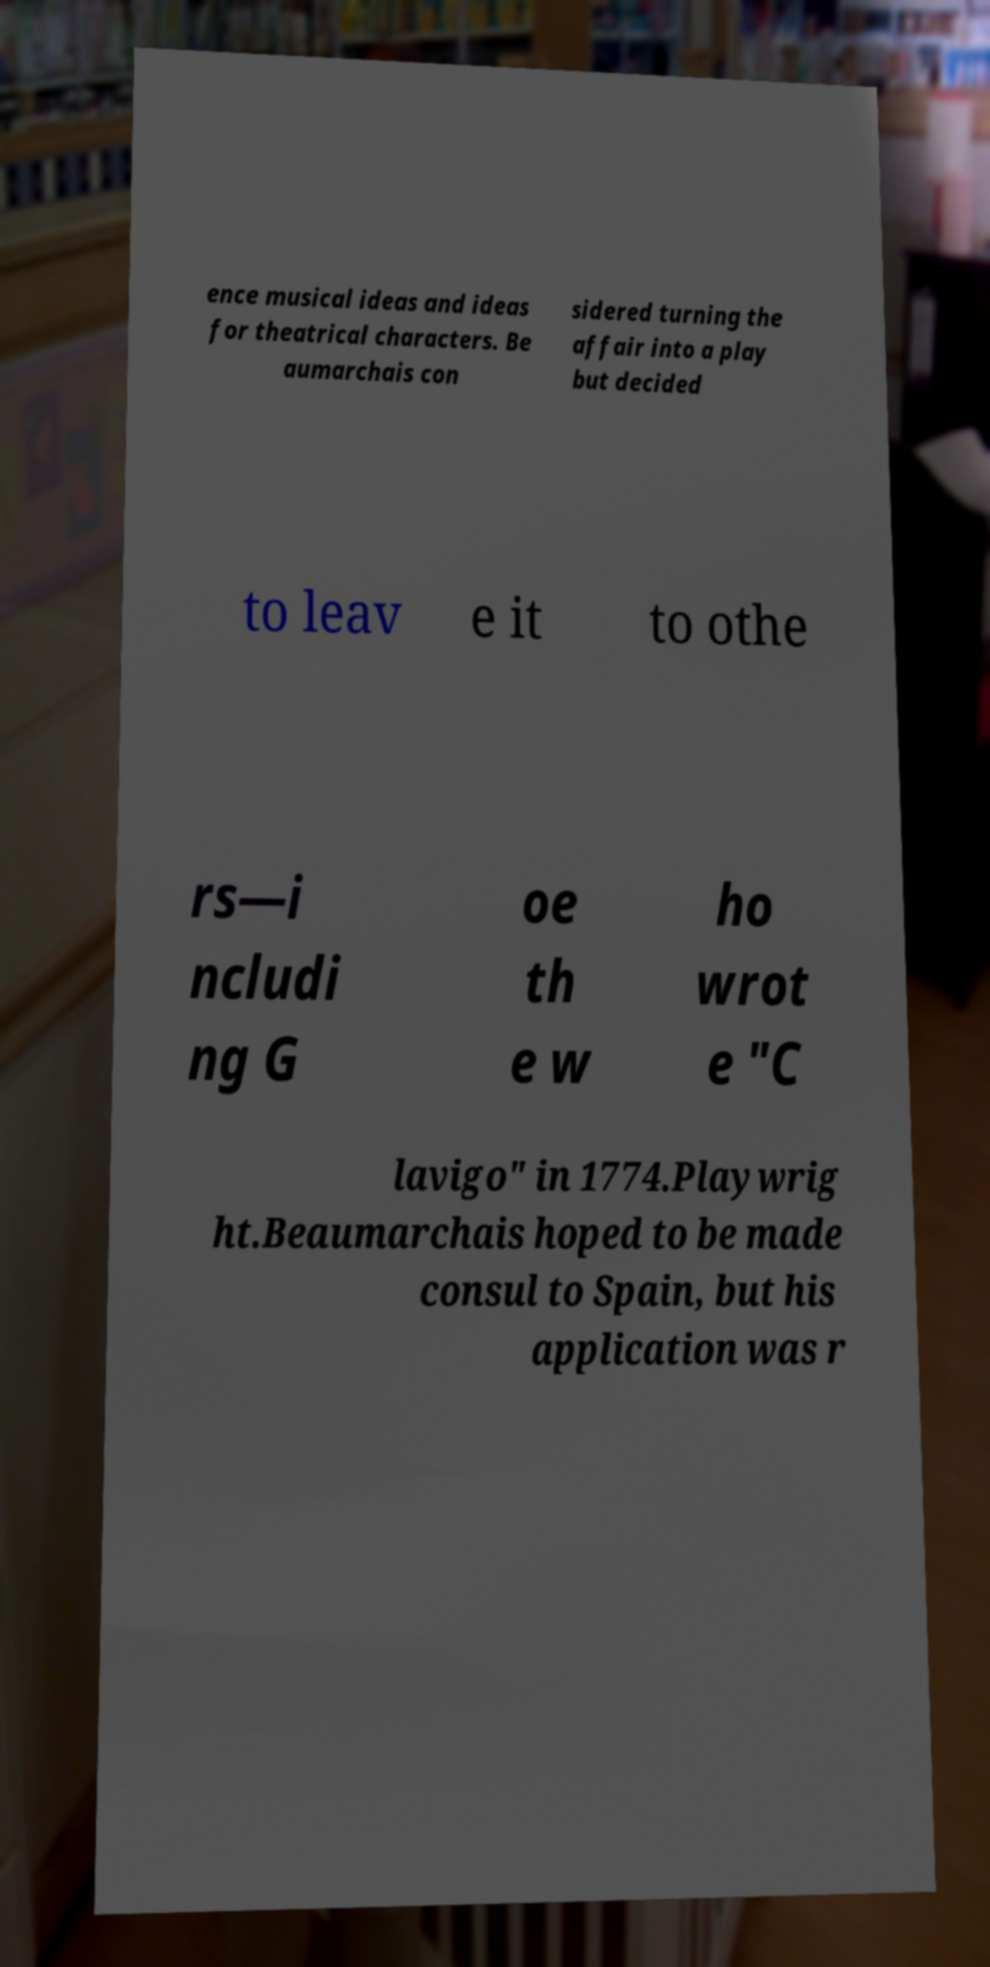Please read and relay the text visible in this image. What does it say? ence musical ideas and ideas for theatrical characters. Be aumarchais con sidered turning the affair into a play but decided to leav e it to othe rs—i ncludi ng G oe th e w ho wrot e "C lavigo" in 1774.Playwrig ht.Beaumarchais hoped to be made consul to Spain, but his application was r 